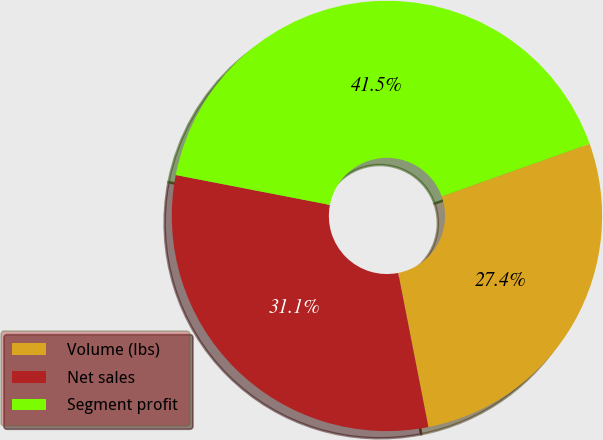<chart> <loc_0><loc_0><loc_500><loc_500><pie_chart><fcel>Volume (lbs)<fcel>Net sales<fcel>Segment profit<nl><fcel>27.36%<fcel>31.13%<fcel>41.51%<nl></chart> 